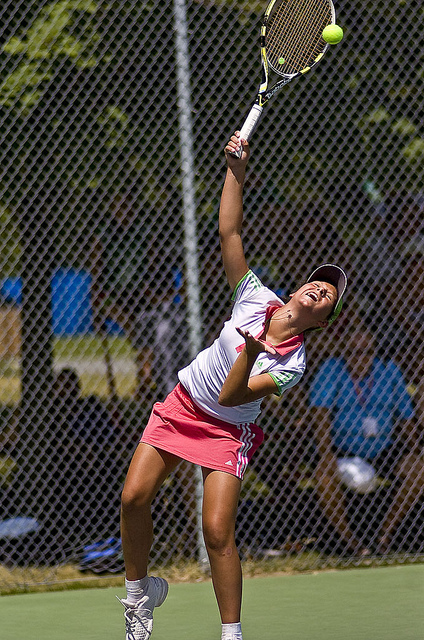<image>What brand of tennis racket is she holding? I am not sure what brand of tennis racket she is holding. It can be Nike, Wilson, Babolat or Dunlop. What team does the woman play for? I don't know what team the woman plays for. It can be tennis or herself, but it is not clear. What brand of tennis racket is she holding? It is unknown what brand of tennis racket she is holding. It is not showing the logo. What team does the woman play for? I don't know what team the woman plays for. 